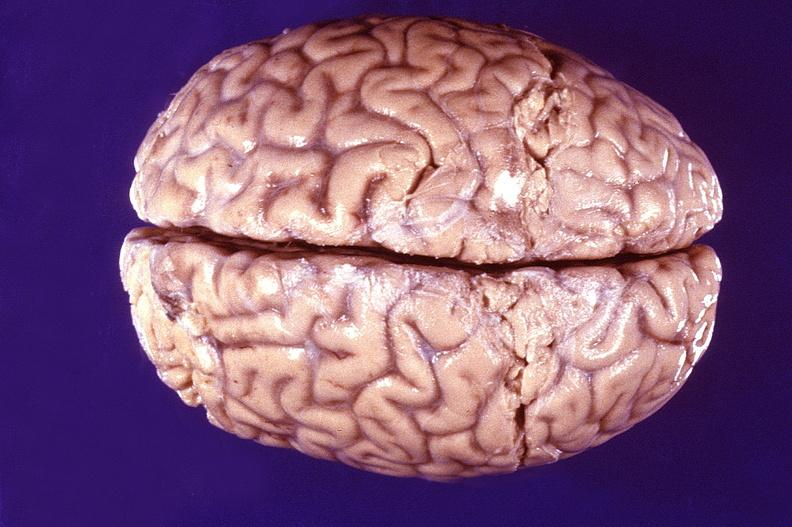s nervous present?
Answer the question using a single word or phrase. Yes 